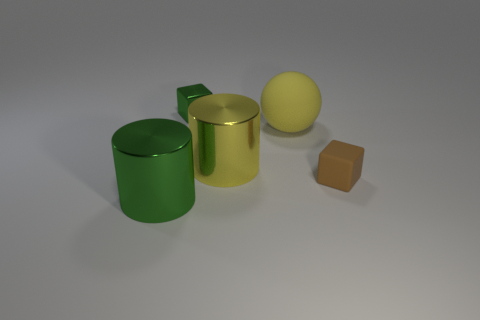What is the overall mood conveyed by the colors in the image? The colors in the image convey a calm and neutral mood. The use of soft lighting and muted, pastel-like colors creates a serene atmosphere. 